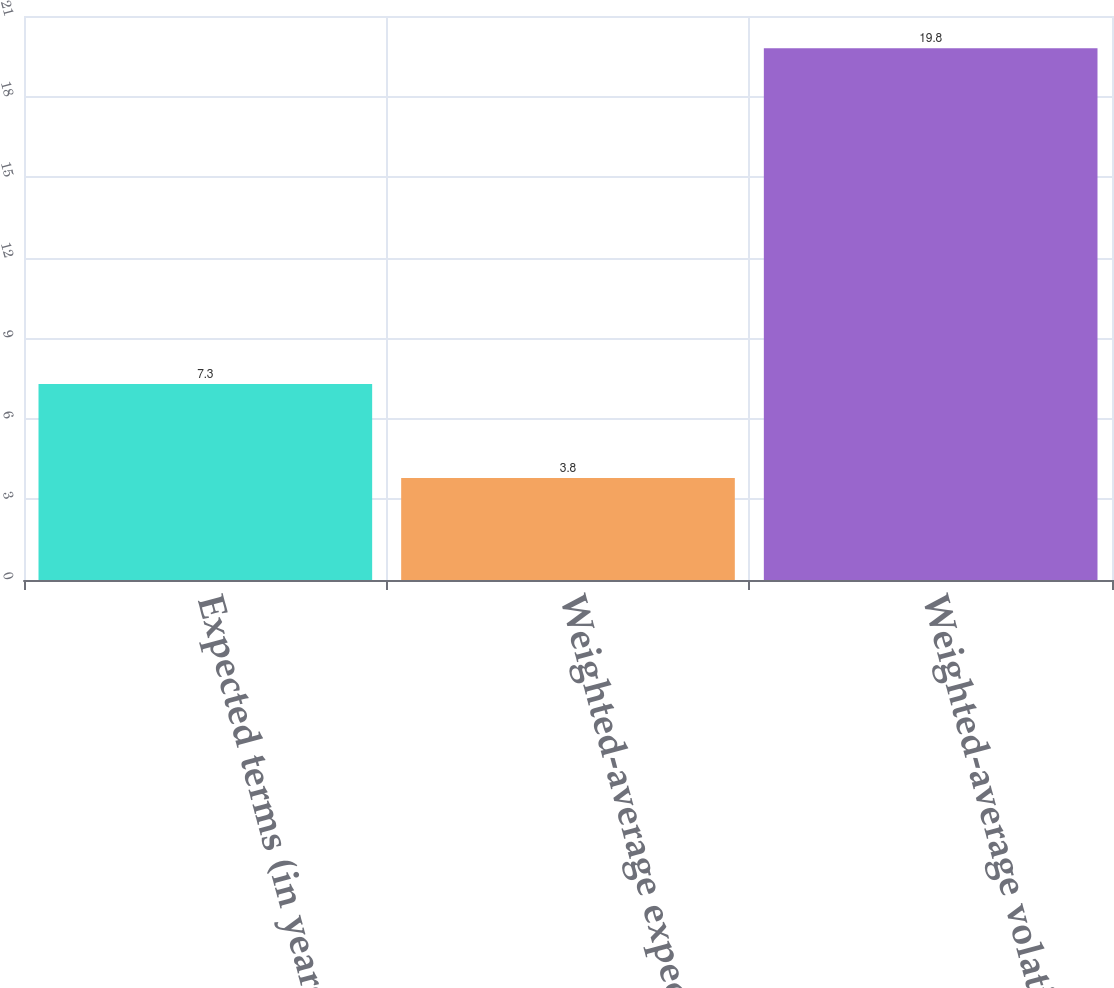<chart> <loc_0><loc_0><loc_500><loc_500><bar_chart><fcel>Expected terms (in years)<fcel>Weighted-average expected<fcel>Weighted-average volatility<nl><fcel>7.3<fcel>3.8<fcel>19.8<nl></chart> 